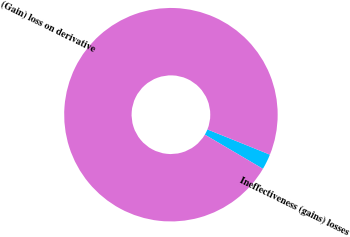<chart> <loc_0><loc_0><loc_500><loc_500><pie_chart><fcel>Ineffectiveness (gains) losses<fcel>(Gain) loss on derivative<nl><fcel>2.36%<fcel>97.64%<nl></chart> 